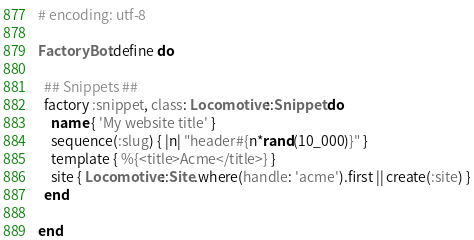<code> <loc_0><loc_0><loc_500><loc_500><_Ruby_># encoding: utf-8

FactoryBot.define do

  ## Snippets ##
  factory :snippet, class: Locomotive::Snippet do
    name { 'My website title' }
    sequence(:slug) { |n| "header#{n*rand(10_000)}" }
    template { %{<title>Acme</title>} }
    site { Locomotive::Site.where(handle: 'acme').first || create(:site) }
  end

end
</code> 